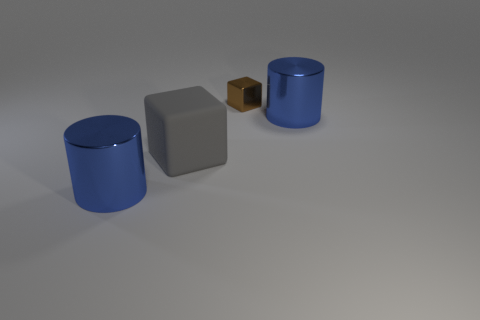How many things are big metallic things or big things?
Give a very brief answer. 3. Are there fewer blue cylinders than small metal cubes?
Offer a very short reply. No. What size is the shiny block?
Offer a very short reply. Small. The gray thing has what shape?
Keep it short and to the point. Cube. There is a thing that is on the left side of the big gray block; does it have the same color as the tiny metal object?
Give a very brief answer. No. There is another thing that is the same shape as the big gray thing; what is its size?
Ensure brevity in your answer.  Small. Is there any other thing that is made of the same material as the large gray thing?
Give a very brief answer. No. There is a large blue metallic object that is behind the cylinder that is on the left side of the tiny brown object; is there a gray matte cube that is behind it?
Your answer should be very brief. No. There is a cylinder that is on the right side of the brown object; what material is it?
Offer a terse response. Metal. What number of big objects are brown shiny objects or purple rubber balls?
Your answer should be compact. 0. 